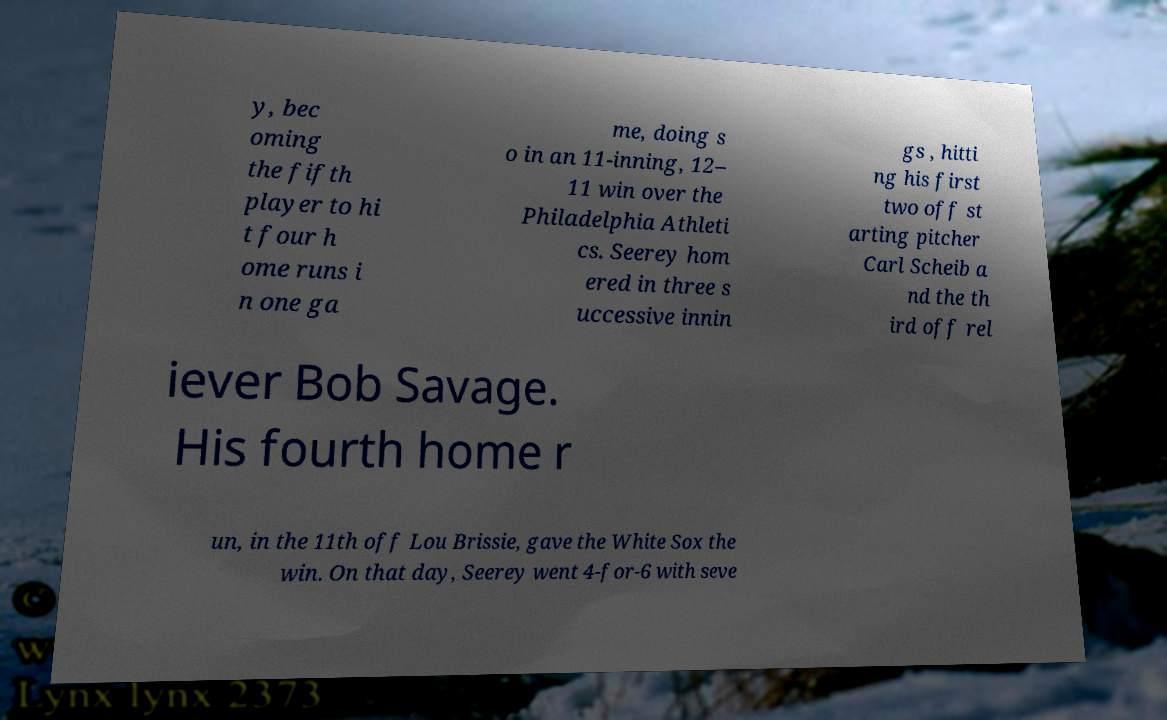I need the written content from this picture converted into text. Can you do that? y, bec oming the fifth player to hi t four h ome runs i n one ga me, doing s o in an 11-inning, 12– 11 win over the Philadelphia Athleti cs. Seerey hom ered in three s uccessive innin gs , hitti ng his first two off st arting pitcher Carl Scheib a nd the th ird off rel iever Bob Savage. His fourth home r un, in the 11th off Lou Brissie, gave the White Sox the win. On that day, Seerey went 4-for-6 with seve 